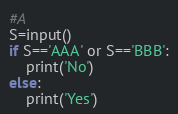<code> <loc_0><loc_0><loc_500><loc_500><_Python_>#A
S=input()
if S=='AAA' or S=='BBB':
    print('No')
else:
    print('Yes')</code> 